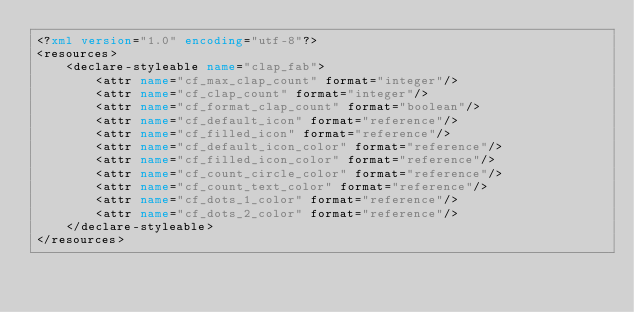<code> <loc_0><loc_0><loc_500><loc_500><_XML_><?xml version="1.0" encoding="utf-8"?>
<resources>
    <declare-styleable name="clap_fab">
        <attr name="cf_max_clap_count" format="integer"/>
        <attr name="cf_clap_count" format="integer"/>
        <attr name="cf_format_clap_count" format="boolean"/>
        <attr name="cf_default_icon" format="reference"/>
        <attr name="cf_filled_icon" format="reference"/>
        <attr name="cf_default_icon_color" format="reference"/>
        <attr name="cf_filled_icon_color" format="reference"/>
        <attr name="cf_count_circle_color" format="reference"/>
        <attr name="cf_count_text_color" format="reference"/>
        <attr name="cf_dots_1_color" format="reference"/>
        <attr name="cf_dots_2_color" format="reference"/>
    </declare-styleable>
</resources></code> 